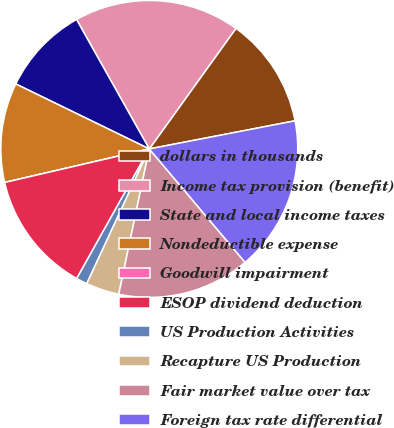<chart> <loc_0><loc_0><loc_500><loc_500><pie_chart><fcel>dollars in thousands<fcel>Income tax provision (benefit)<fcel>State and local income taxes<fcel>Nondeductible expense<fcel>Goodwill impairment<fcel>ESOP dividend deduction<fcel>US Production Activities<fcel>Recapture US Production<fcel>Fair market value over tax<fcel>Foreign tax rate differential<nl><fcel>12.05%<fcel>18.07%<fcel>9.64%<fcel>10.84%<fcel>0.0%<fcel>13.25%<fcel>1.21%<fcel>3.62%<fcel>14.46%<fcel>16.87%<nl></chart> 